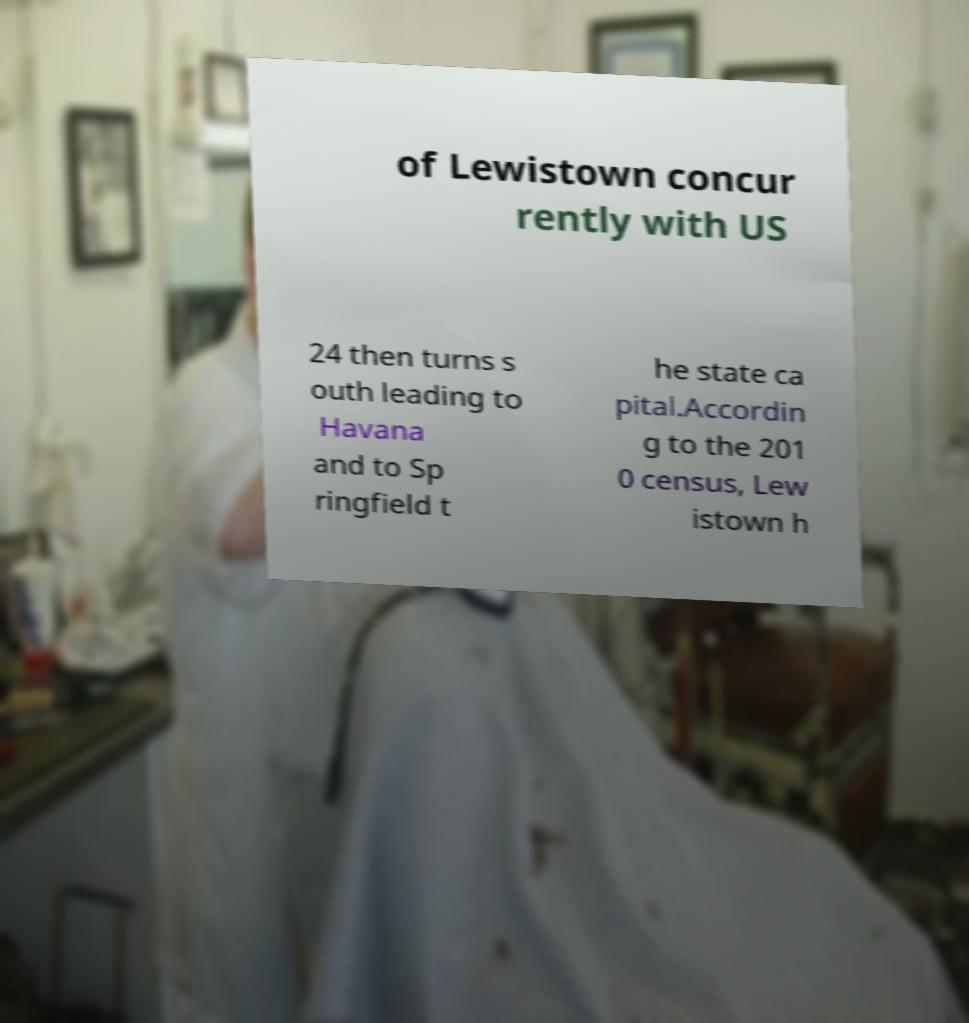Could you extract and type out the text from this image? of Lewistown concur rently with US 24 then turns s outh leading to Havana and to Sp ringfield t he state ca pital.Accordin g to the 201 0 census, Lew istown h 